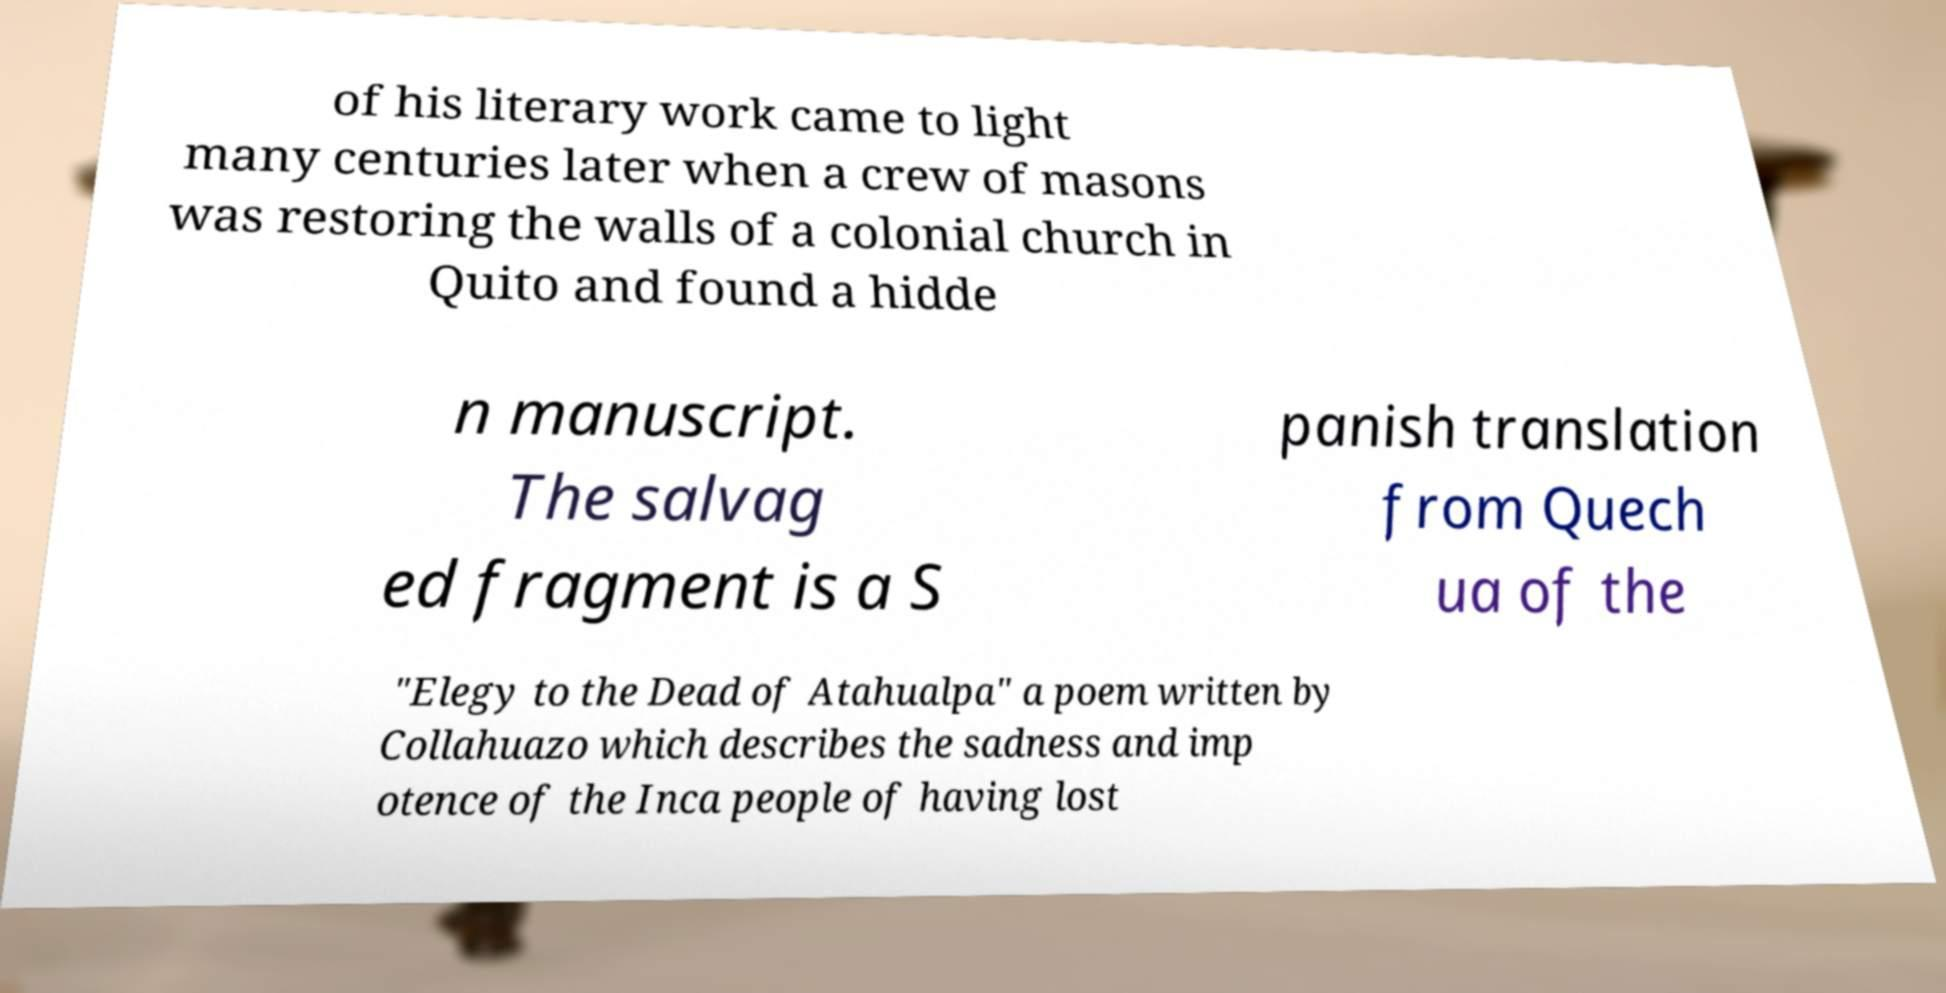Can you accurately transcribe the text from the provided image for me? of his literary work came to light many centuries later when a crew of masons was restoring the walls of a colonial church in Quito and found a hidde n manuscript. The salvag ed fragment is a S panish translation from Quech ua of the "Elegy to the Dead of Atahualpa" a poem written by Collahuazo which describes the sadness and imp otence of the Inca people of having lost 